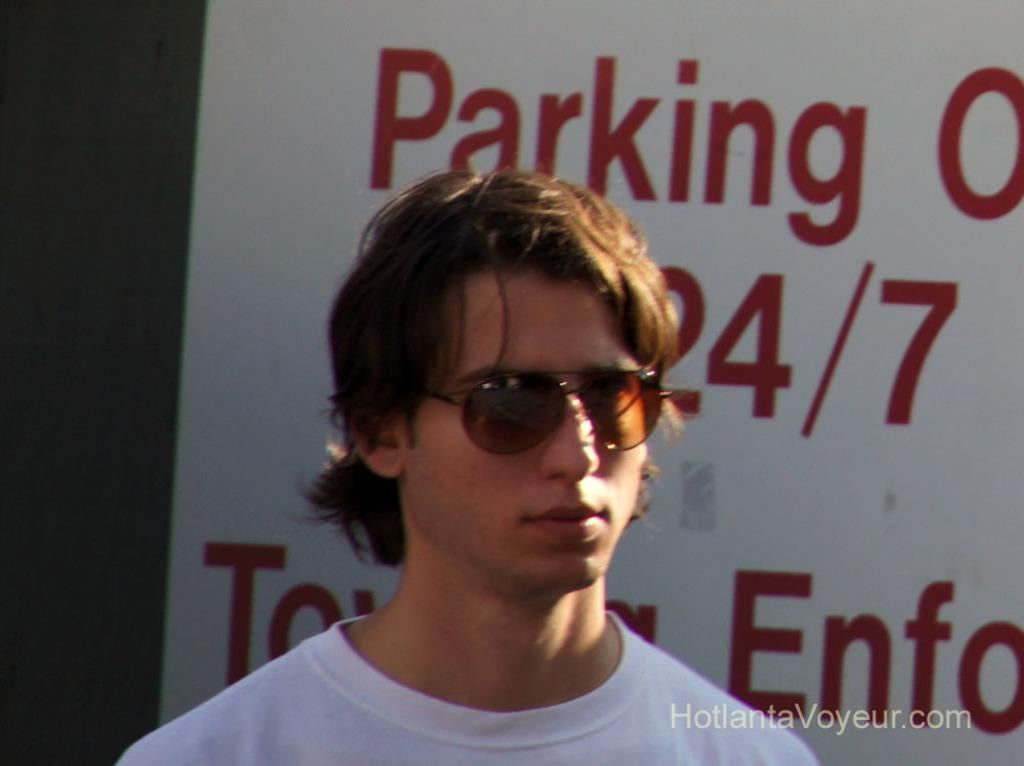Who or what is the main subject in the image? There is a person in the image. What is located behind the person? There is a whiteboard behind the person. What can be seen on the whiteboard? There is text on the whiteboard. What type of juice is being served to the person's father in the image? There is no juice or father present in the image; it only features a person and a whiteboard with text. 